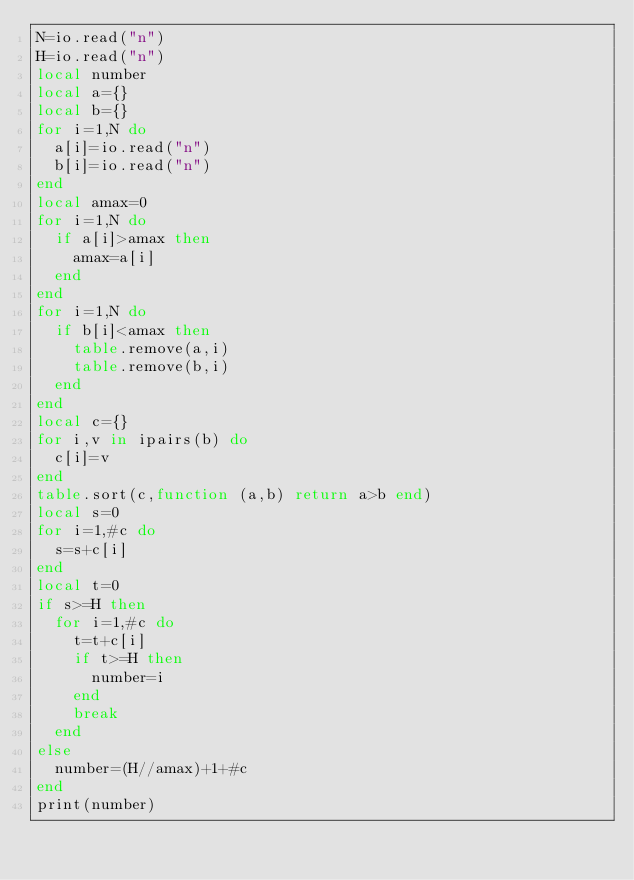Convert code to text. <code><loc_0><loc_0><loc_500><loc_500><_Lua_>N=io.read("n")
H=io.read("n")
local number
local a={}
local b={}
for i=1,N do
  a[i]=io.read("n")
  b[i]=io.read("n")
end
local amax=0
for i=1,N do
  if a[i]>amax then
    amax=a[i]
  end
end
for i=1,N do
  if b[i]<amax then
    table.remove(a,i)
    table.remove(b,i)
  end
end
local c={}
for i,v in ipairs(b) do
  c[i]=v
end
table.sort(c,function (a,b) return a>b end)
local s=0
for i=1,#c do
  s=s+c[i]
end
local t=0
if s>=H then
  for i=1,#c do
    t=t+c[i]
    if t>=H then
      number=i
    end
    break
  end
else
  number=(H//amax)+1+#c
end
print(number)</code> 